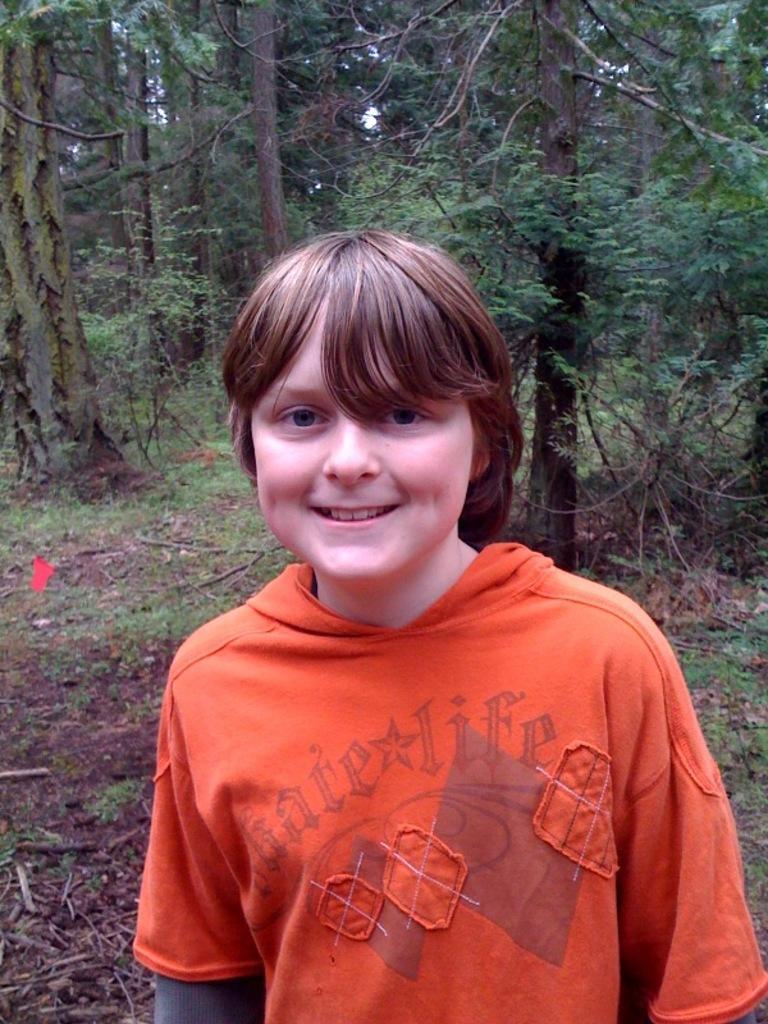Could you give a brief overview of what you see in this image? As we can see in the image in the front there is a boy wearing orange color jacket and in the background there are trees. 